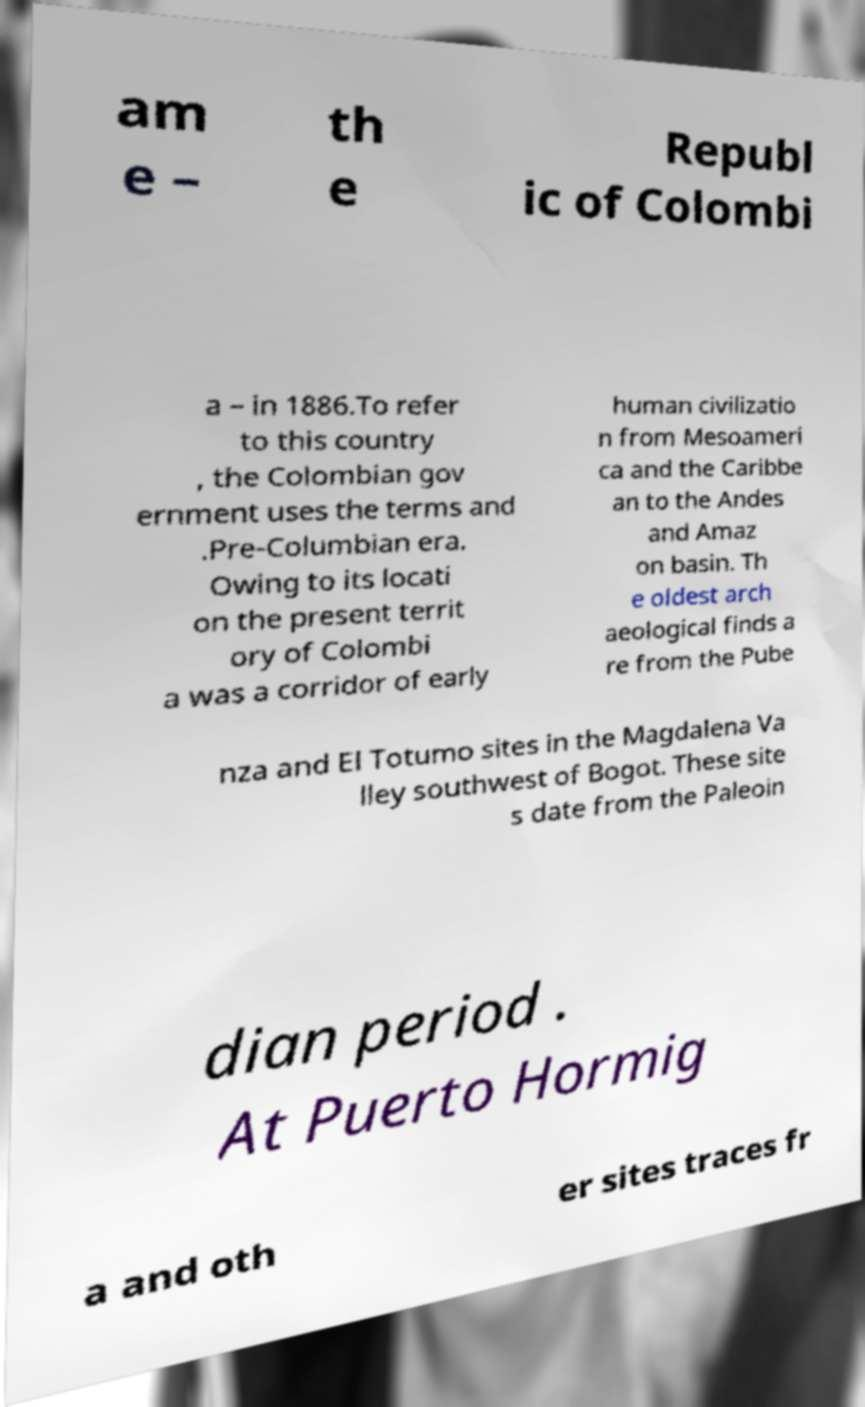Could you assist in decoding the text presented in this image and type it out clearly? am e – th e Republ ic of Colombi a – in 1886.To refer to this country , the Colombian gov ernment uses the terms and .Pre-Columbian era. Owing to its locati on the present territ ory of Colombi a was a corridor of early human civilizatio n from Mesoameri ca and the Caribbe an to the Andes and Amaz on basin. Th e oldest arch aeological finds a re from the Pube nza and El Totumo sites in the Magdalena Va lley southwest of Bogot. These site s date from the Paleoin dian period . At Puerto Hormig a and oth er sites traces fr 